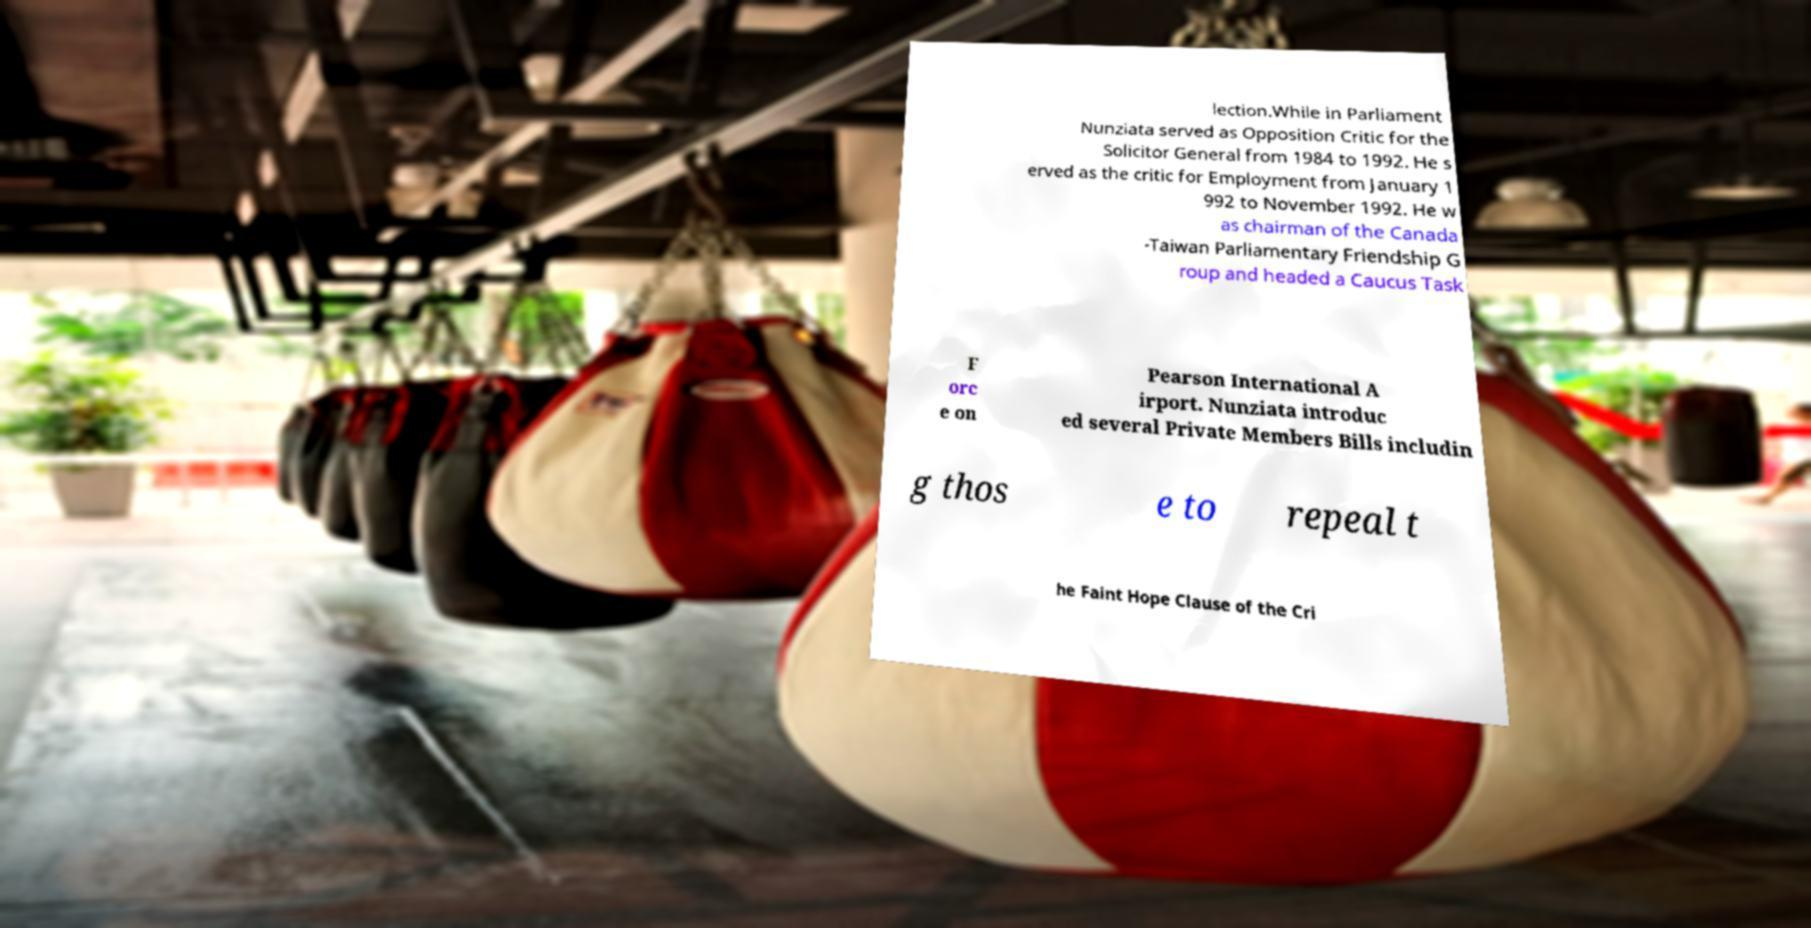Please read and relay the text visible in this image. What does it say? lection.While in Parliament Nunziata served as Opposition Critic for the Solicitor General from 1984 to 1992. He s erved as the critic for Employment from January 1 992 to November 1992. He w as chairman of the Canada -Taiwan Parliamentary Friendship G roup and headed a Caucus Task F orc e on Pearson International A irport. Nunziata introduc ed several Private Members Bills includin g thos e to repeal t he Faint Hope Clause of the Cri 